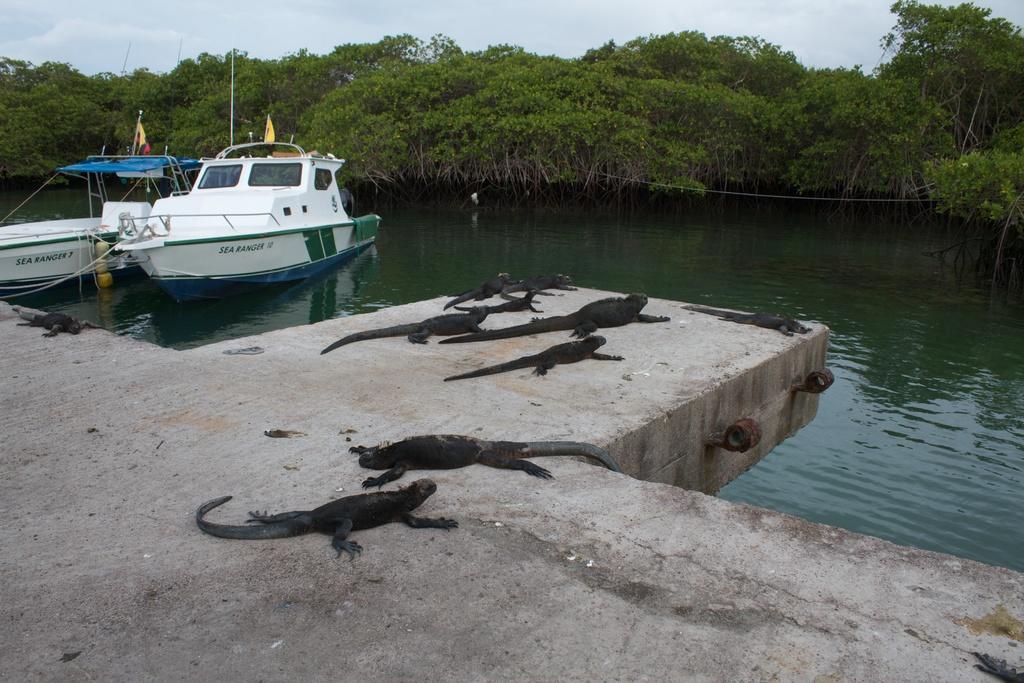In one or two sentences, can you explain what this image depicts? In this image there are two boats in the water. In the background there are trees. At the bottom there is a floor on which there are small crocodiles. At the top there is sky. 